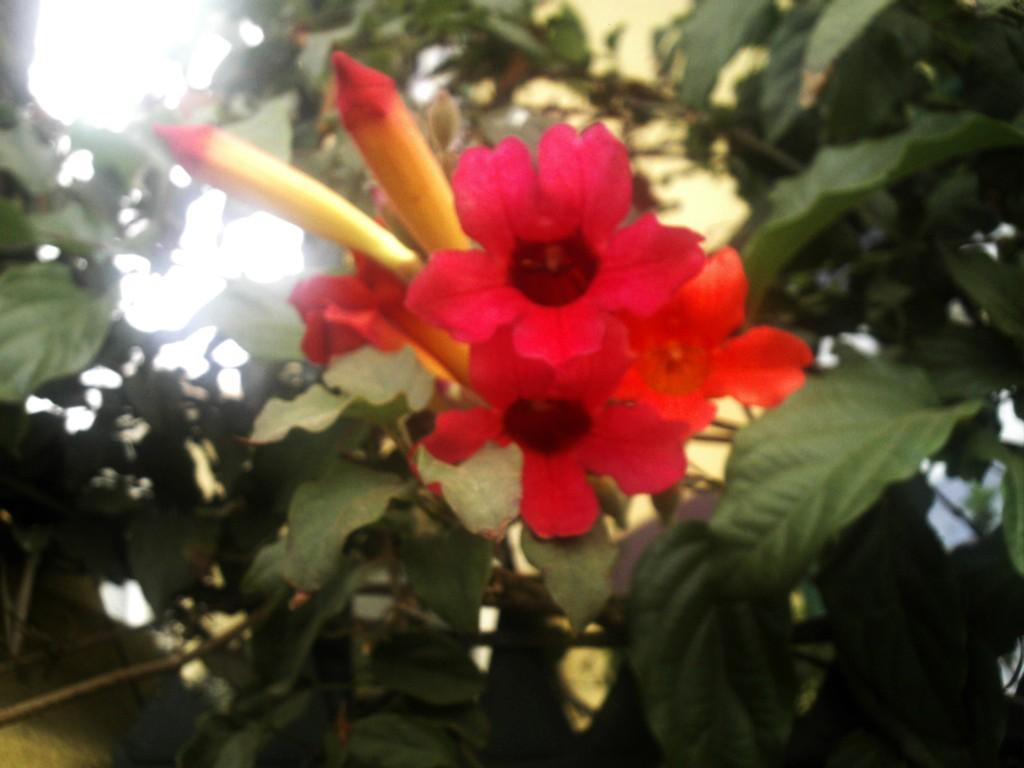What is the main subject in the center of the image? There are flowers in the center of the image. What can be seen in the background of the image? There are leaves in the background of the image. What type of bear can be seen hiding behind the flowers in the image? There is no bear present in the image; it features only flowers and leaves. How many clovers are visible among the flowers in the image? There is no mention of clovers in the image; it only features flowers and leaves. 